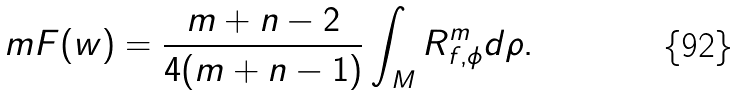<formula> <loc_0><loc_0><loc_500><loc_500>\ m F ( w ) = \frac { m + n - 2 } { 4 ( m + n - 1 ) } \int _ { M } R _ { f , \phi } ^ { m } d \rho .</formula> 